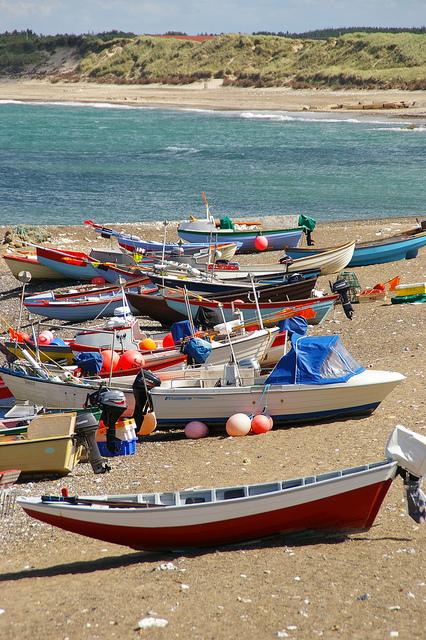Are the vessels shown seaworthy?
Answer briefly. Yes. What is beside the second boat?
Be succinct. Balloons. How many boats are pictured?
Quick response, please. 10. Is this a calm picture?
Write a very short answer. Yes. What is the name of the boat pictured?
Quick response, please. Dinghy. Is there a lake in this picture?
Keep it brief. Yes. Can you see the sun?
Keep it brief. No. 